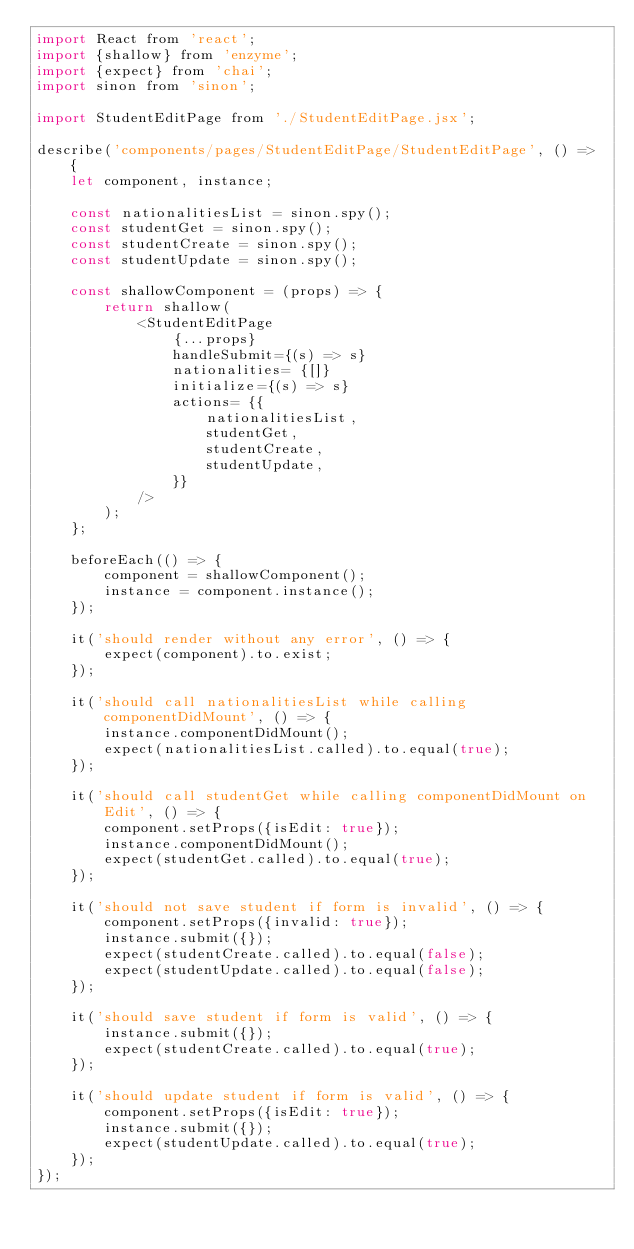<code> <loc_0><loc_0><loc_500><loc_500><_JavaScript_>import React from 'react';
import {shallow} from 'enzyme';
import {expect} from 'chai';
import sinon from 'sinon';

import StudentEditPage from './StudentEditPage.jsx';

describe('components/pages/StudentEditPage/StudentEditPage', () => {
    let component, instance;

    const nationalitiesList = sinon.spy();
    const studentGet = sinon.spy();
    const studentCreate = sinon.spy();
    const studentUpdate = sinon.spy();    

    const shallowComponent = (props) => {
        return shallow(
            <StudentEditPage
                {...props}
                handleSubmit={(s) => s}
                nationalities= {[]}
                initialize={(s) => s}                
                actions= {{
                    nationalitiesList,
                    studentGet,
                    studentCreate,
                    studentUpdate,
                }}
            />
        );
    };

    beforeEach(() => {        
        component = shallowComponent();
        instance = component.instance();
    });
    
    it('should render without any error', () => {
        expect(component).to.exist;
    });

    it('should call nationalitiesList while calling componentDidMount', () => {
        instance.componentDidMount();
        expect(nationalitiesList.called).to.equal(true);
    });

    it('should call studentGet while calling componentDidMount on Edit', () => {
        component.setProps({isEdit: true});
        instance.componentDidMount();
        expect(studentGet.called).to.equal(true);
    });

    it('should not save student if form is invalid', () => {
        component.setProps({invalid: true});
        instance.submit({});
        expect(studentCreate.called).to.equal(false);
        expect(studentUpdate.called).to.equal(false);
    });

    it('should save student if form is valid', () => {
        instance.submit({});
        expect(studentCreate.called).to.equal(true);
    });

    it('should update student if form is valid', () => {
        component.setProps({isEdit: true});
        instance.submit({});
        expect(studentUpdate.called).to.equal(true);
    });
});</code> 